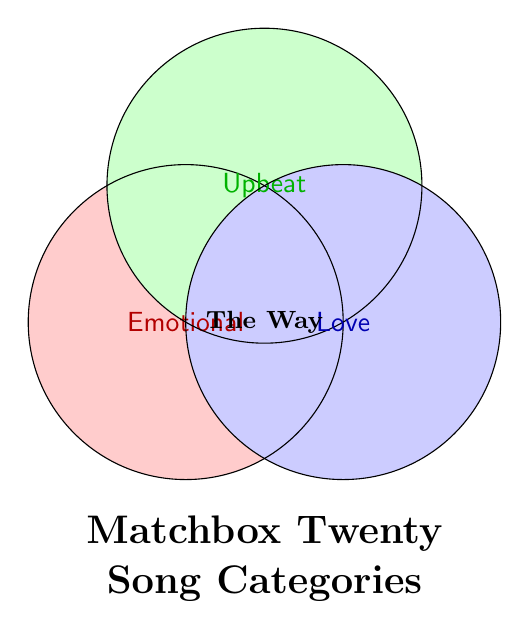How many song categories does the figure depict? The figure has three circles, each representing a different category.
Answer: 3 Which song fits into the intersection of Emotional, Upbeat, and Love categories? The song "The Way" is positioned at the intersection of all three circles (Emotional, Upbeat, and Love), indicating it belongs to all three categories.
Answer: The Way What are the names of the three categories in the Venn diagram? The names of the categories are written inside each circle: Emotional, Upbeat, and Love.
Answer: Emotional, Upbeat, Love What is the title of the Venn diagram? The title is provided in larger, bold font below the circles.
Answer: Matchbox Twenty Song Categories Which category is colored red? The color red is used to fill the circle labeled "Emotional."
Answer: Emotional Compare the number of songs in each category Since there is only one song ("The Way") that fits into all the categories, every category has the same number of songs, which is one.
Answer: Same (1) Which category contains upbeat songs? The "Upbeat" category is explicitly labeled, and has green coloration.
Answer: Upbeat If a new song is added in the same area as "The Way," how many categories would it belong to? "The Way" is in the intersection of all three circles, meaning a song added in the same area would belong to three categories.
Answer: 3 How many songs are there in total in the diagram? The diagram contains only one song ("The Way").
Answer: 1 